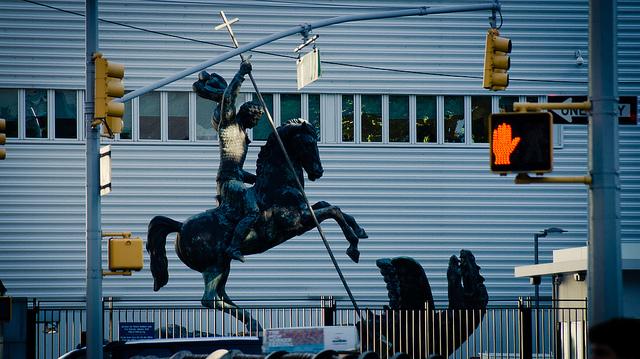What is the man on the horse attacking?
Write a very short answer. Dragon. Is the horse and rider waiting for the signal?
Be succinct. No. Does the crossing sign signaling people to stop?
Give a very brief answer. Yes. 